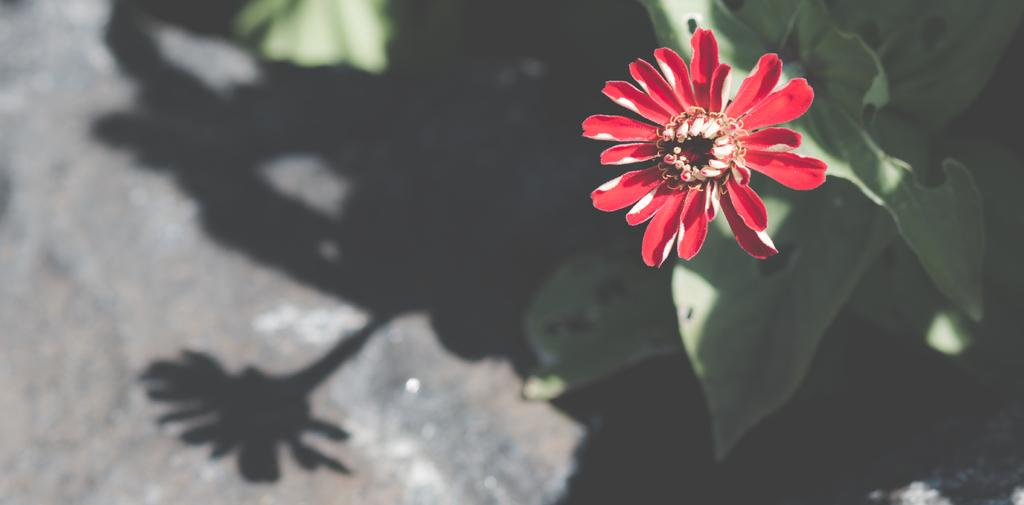What type of flower is in the image? There is a red color flower in the image. How many petals does the flower have? The flower has few petals. What else can be seen in the image besides the flower? There are leaves in the image. What is the result of the plant's presence in the image? There is a shadow of the plant on the floor in the image. What is the son's account number in the image? There is no son or account number present in the image; it features a red color flower with few petals, leaves, and a shadow on the floor. 